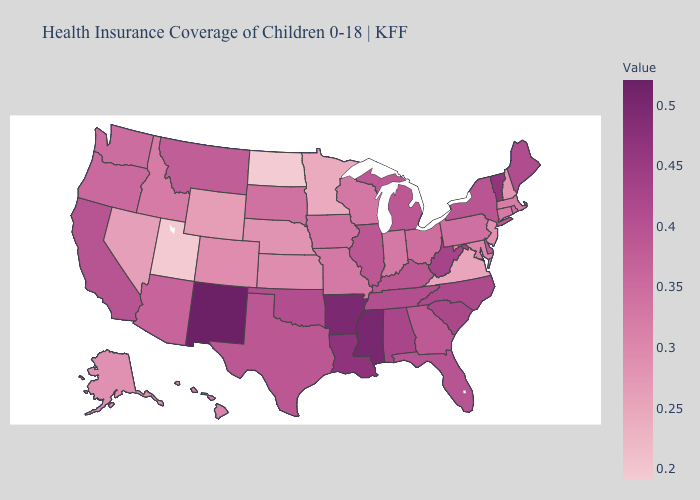Which states have the lowest value in the USA?
Write a very short answer. North Dakota. Does Tennessee have a higher value than Mississippi?
Keep it brief. No. Which states have the highest value in the USA?
Concise answer only. New Mexico. Does Utah have a lower value than Wyoming?
Write a very short answer. Yes. Does Ohio have a higher value than Georgia?
Quick response, please. No. Does Idaho have the highest value in the USA?
Give a very brief answer. No. Which states have the highest value in the USA?
Quick response, please. New Mexico. Does Nevada have a lower value than South Carolina?
Write a very short answer. Yes. 